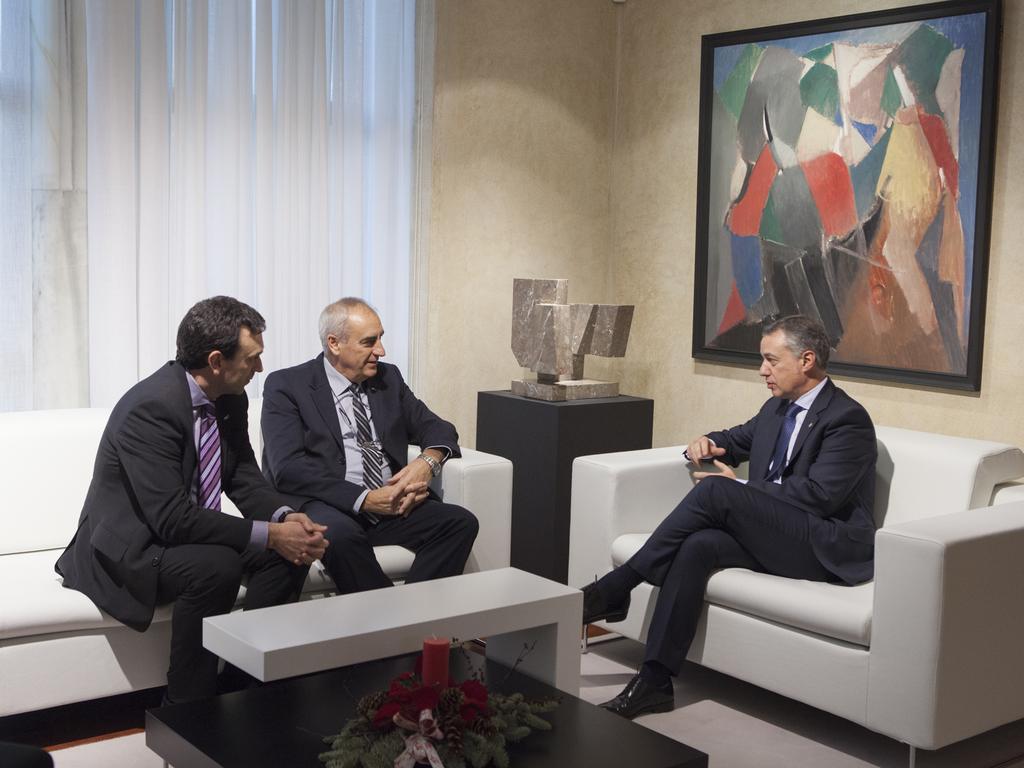In one or two sentences, can you explain what this image depicts? In this picture there are three people sitting on the sofa there is a white table in between the sofa and flower, there is a portrait on the wall, there are white curtains at the right side of the image. 